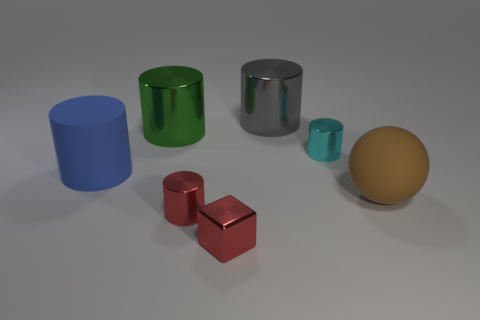Subtract all big cylinders. How many cylinders are left? 2 Add 3 metal things. How many objects exist? 10 Subtract 1 cylinders. How many cylinders are left? 4 Subtract all gray cylinders. How many cylinders are left? 4 Subtract all cylinders. How many objects are left? 2 Subtract all green cubes. Subtract all gray spheres. How many cubes are left? 1 Subtract all green cubes. How many green balls are left? 0 Subtract all large cyan shiny blocks. Subtract all rubber spheres. How many objects are left? 6 Add 2 rubber cylinders. How many rubber cylinders are left? 3 Add 7 brown rubber objects. How many brown rubber objects exist? 8 